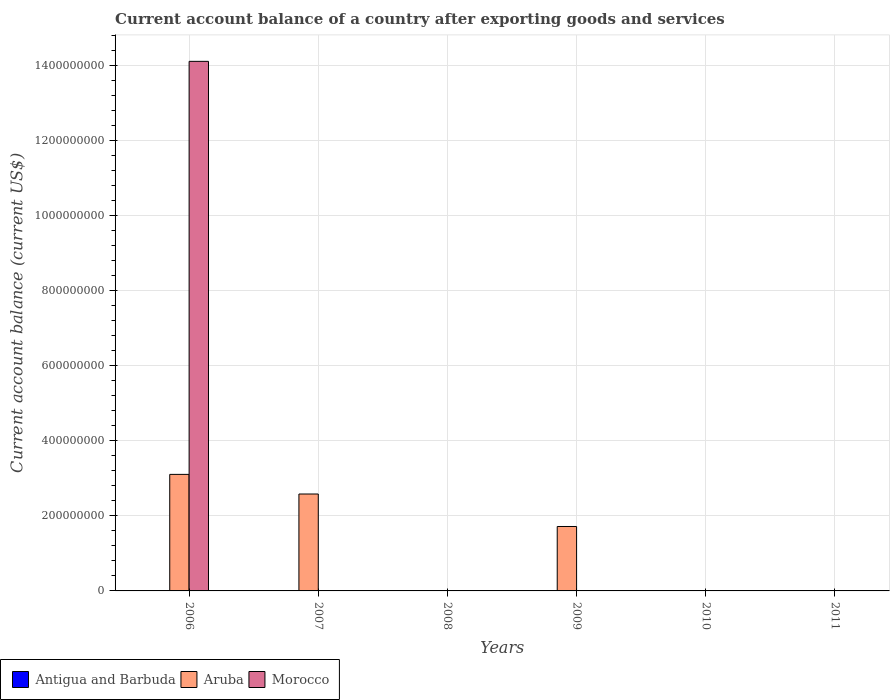Are the number of bars per tick equal to the number of legend labels?
Make the answer very short. No. Are the number of bars on each tick of the X-axis equal?
Ensure brevity in your answer.  No. How many bars are there on the 5th tick from the left?
Offer a terse response. 0. How many bars are there on the 2nd tick from the right?
Your answer should be compact. 0. What is the label of the 2nd group of bars from the left?
Your answer should be compact. 2007. What is the account balance in Morocco in 2010?
Your answer should be compact. 0. Across all years, what is the maximum account balance in Morocco?
Provide a succinct answer. 1.41e+09. In which year was the account balance in Morocco maximum?
Offer a very short reply. 2006. What is the total account balance in Antigua and Barbuda in the graph?
Your answer should be very brief. 0. What is the difference between the account balance in Aruba in 2006 and that in 2009?
Keep it short and to the point. 1.39e+08. What is the difference between the account balance in Morocco in 2007 and the account balance in Antigua and Barbuda in 2010?
Provide a short and direct response. 0. In how many years, is the account balance in Aruba greater than 400000000 US$?
Ensure brevity in your answer.  0. What is the ratio of the account balance in Aruba in 2007 to that in 2009?
Your answer should be very brief. 1.5. What is the difference between the highest and the second highest account balance in Aruba?
Provide a succinct answer. 5.23e+07. What is the difference between the highest and the lowest account balance in Morocco?
Offer a very short reply. 1.41e+09. In how many years, is the account balance in Morocco greater than the average account balance in Morocco taken over all years?
Provide a succinct answer. 1. Is it the case that in every year, the sum of the account balance in Aruba and account balance in Antigua and Barbuda is greater than the account balance in Morocco?
Your answer should be very brief. No. How many years are there in the graph?
Provide a short and direct response. 6. What is the difference between two consecutive major ticks on the Y-axis?
Offer a terse response. 2.00e+08. Does the graph contain grids?
Your response must be concise. Yes. How many legend labels are there?
Offer a very short reply. 3. How are the legend labels stacked?
Ensure brevity in your answer.  Horizontal. What is the title of the graph?
Your answer should be very brief. Current account balance of a country after exporting goods and services. What is the label or title of the Y-axis?
Ensure brevity in your answer.  Current account balance (current US$). What is the Current account balance (current US$) in Aruba in 2006?
Make the answer very short. 3.11e+08. What is the Current account balance (current US$) in Morocco in 2006?
Your response must be concise. 1.41e+09. What is the Current account balance (current US$) of Antigua and Barbuda in 2007?
Your response must be concise. 0. What is the Current account balance (current US$) in Aruba in 2007?
Provide a succinct answer. 2.58e+08. What is the Current account balance (current US$) of Aruba in 2008?
Offer a very short reply. 1.12e+05. What is the Current account balance (current US$) of Antigua and Barbuda in 2009?
Provide a succinct answer. 0. What is the Current account balance (current US$) in Aruba in 2009?
Your answer should be very brief. 1.72e+08. What is the Current account balance (current US$) in Aruba in 2010?
Your answer should be compact. 0. What is the Current account balance (current US$) of Antigua and Barbuda in 2011?
Your response must be concise. 0. Across all years, what is the maximum Current account balance (current US$) of Aruba?
Ensure brevity in your answer.  3.11e+08. Across all years, what is the maximum Current account balance (current US$) in Morocco?
Give a very brief answer. 1.41e+09. Across all years, what is the minimum Current account balance (current US$) in Morocco?
Your answer should be very brief. 0. What is the total Current account balance (current US$) of Antigua and Barbuda in the graph?
Provide a succinct answer. 0. What is the total Current account balance (current US$) of Aruba in the graph?
Give a very brief answer. 7.41e+08. What is the total Current account balance (current US$) in Morocco in the graph?
Keep it short and to the point. 1.41e+09. What is the difference between the Current account balance (current US$) in Aruba in 2006 and that in 2007?
Keep it short and to the point. 5.23e+07. What is the difference between the Current account balance (current US$) of Aruba in 2006 and that in 2008?
Ensure brevity in your answer.  3.10e+08. What is the difference between the Current account balance (current US$) in Aruba in 2006 and that in 2009?
Your answer should be very brief. 1.39e+08. What is the difference between the Current account balance (current US$) in Aruba in 2007 and that in 2008?
Make the answer very short. 2.58e+08. What is the difference between the Current account balance (current US$) in Aruba in 2007 and that in 2009?
Provide a succinct answer. 8.66e+07. What is the difference between the Current account balance (current US$) of Aruba in 2008 and that in 2009?
Offer a terse response. -1.72e+08. What is the average Current account balance (current US$) of Antigua and Barbuda per year?
Provide a short and direct response. 0. What is the average Current account balance (current US$) of Aruba per year?
Your answer should be compact. 1.23e+08. What is the average Current account balance (current US$) in Morocco per year?
Offer a terse response. 2.35e+08. In the year 2006, what is the difference between the Current account balance (current US$) of Aruba and Current account balance (current US$) of Morocco?
Make the answer very short. -1.10e+09. What is the ratio of the Current account balance (current US$) of Aruba in 2006 to that in 2007?
Your answer should be very brief. 1.2. What is the ratio of the Current account balance (current US$) of Aruba in 2006 to that in 2008?
Keep it short and to the point. 2779.47. What is the ratio of the Current account balance (current US$) of Aruba in 2006 to that in 2009?
Make the answer very short. 1.81. What is the ratio of the Current account balance (current US$) in Aruba in 2007 to that in 2008?
Keep it short and to the point. 2311.5. What is the ratio of the Current account balance (current US$) of Aruba in 2007 to that in 2009?
Your response must be concise. 1.5. What is the ratio of the Current account balance (current US$) of Aruba in 2008 to that in 2009?
Your answer should be very brief. 0. What is the difference between the highest and the second highest Current account balance (current US$) in Aruba?
Ensure brevity in your answer.  5.23e+07. What is the difference between the highest and the lowest Current account balance (current US$) of Aruba?
Keep it short and to the point. 3.11e+08. What is the difference between the highest and the lowest Current account balance (current US$) of Morocco?
Offer a very short reply. 1.41e+09. 